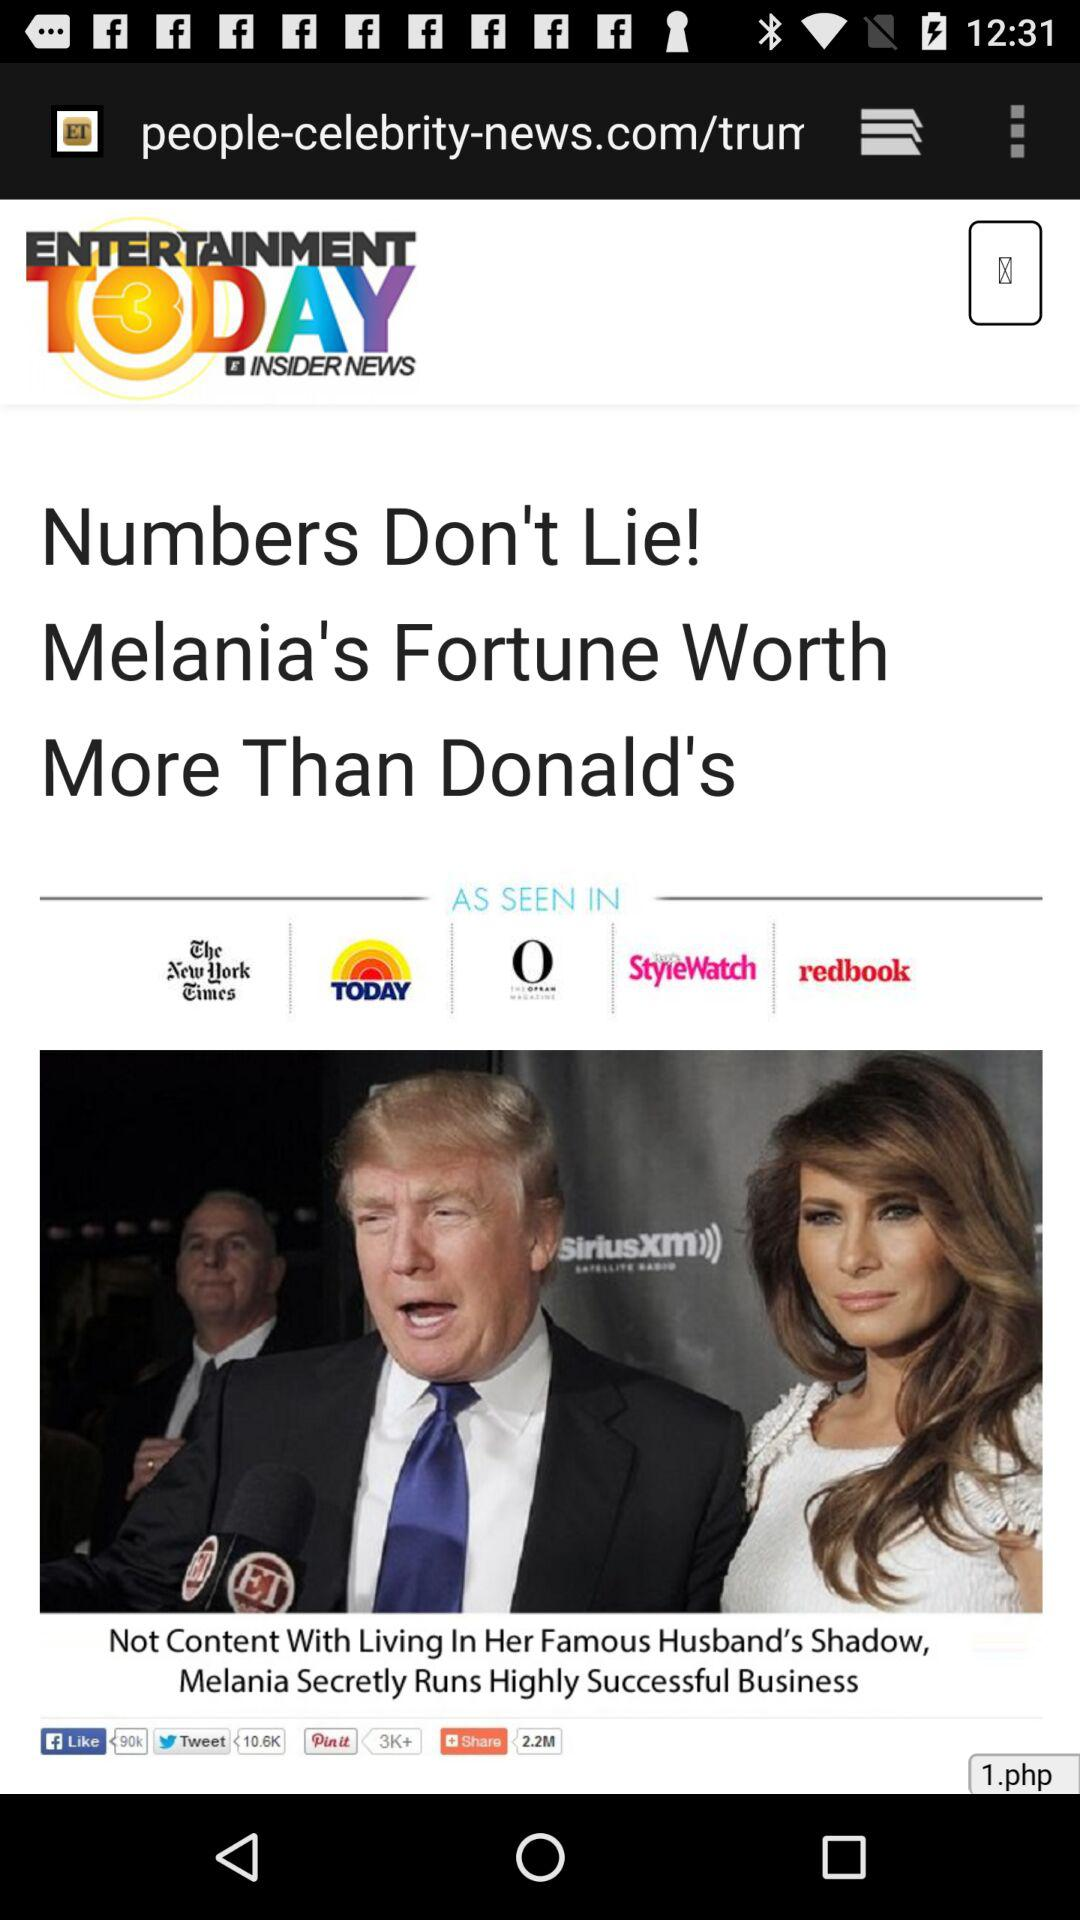What is the name of news channel?
When the provided information is insufficient, respond with <no answer>. <no answer> 